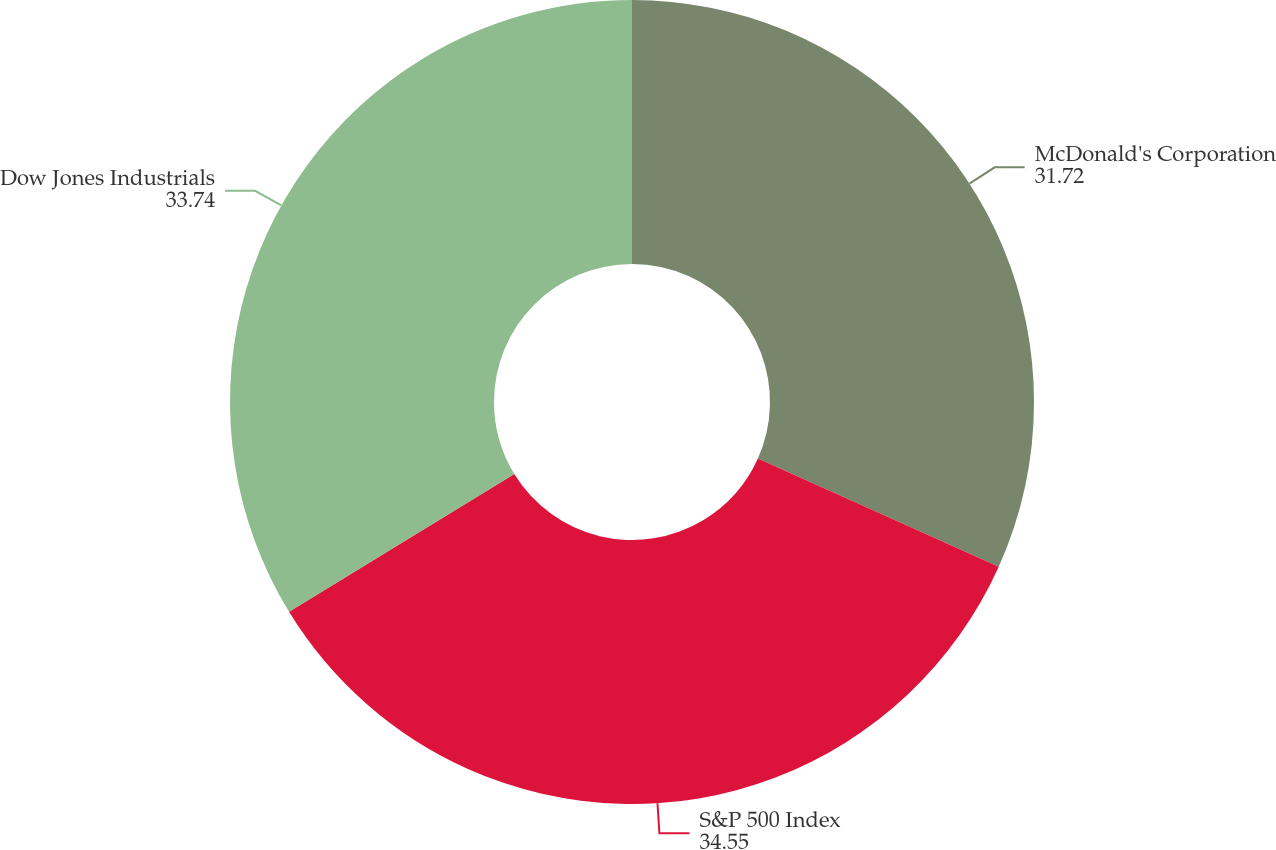Convert chart. <chart><loc_0><loc_0><loc_500><loc_500><pie_chart><fcel>McDonald's Corporation<fcel>S&P 500 Index<fcel>Dow Jones Industrials<nl><fcel>31.72%<fcel>34.55%<fcel>33.74%<nl></chart> 